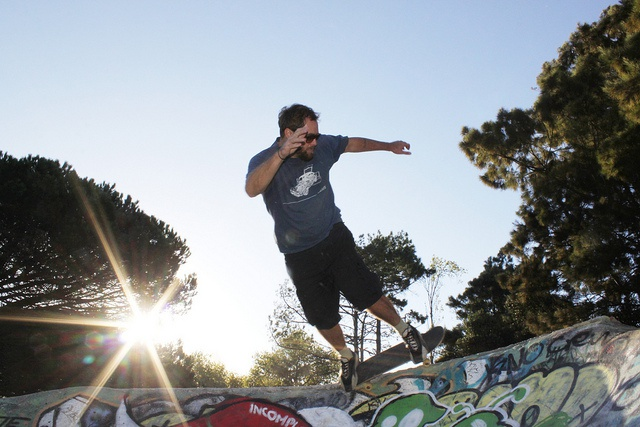Describe the objects in this image and their specific colors. I can see people in lightblue, black, and gray tones and skateboard in lightblue, black, and gray tones in this image. 